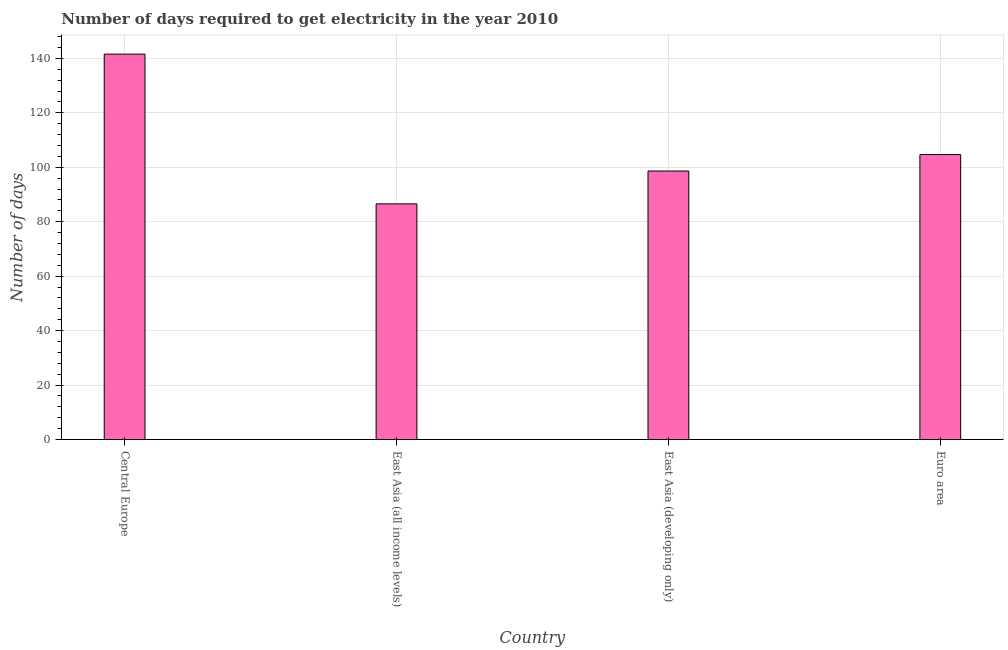Does the graph contain any zero values?
Keep it short and to the point. No. What is the title of the graph?
Provide a succinct answer. Number of days required to get electricity in the year 2010. What is the label or title of the X-axis?
Your answer should be very brief. Country. What is the label or title of the Y-axis?
Offer a very short reply. Number of days. What is the time to get electricity in East Asia (developing only)?
Make the answer very short. 98.61. Across all countries, what is the maximum time to get electricity?
Your answer should be compact. 141.55. Across all countries, what is the minimum time to get electricity?
Make the answer very short. 86.56. In which country was the time to get electricity maximum?
Your response must be concise. Central Europe. In which country was the time to get electricity minimum?
Give a very brief answer. East Asia (all income levels). What is the sum of the time to get electricity?
Ensure brevity in your answer.  431.38. What is the difference between the time to get electricity in Central Europe and East Asia (all income levels)?
Your answer should be compact. 54.98. What is the average time to get electricity per country?
Make the answer very short. 107.85. What is the median time to get electricity?
Provide a short and direct response. 101.64. In how many countries, is the time to get electricity greater than 40 ?
Your answer should be very brief. 4. What is the ratio of the time to get electricity in East Asia (all income levels) to that in East Asia (developing only)?
Your answer should be very brief. 0.88. Is the difference between the time to get electricity in East Asia (all income levels) and East Asia (developing only) greater than the difference between any two countries?
Offer a very short reply. No. What is the difference between the highest and the second highest time to get electricity?
Keep it short and to the point. 36.88. Is the sum of the time to get electricity in Central Europe and East Asia (all income levels) greater than the maximum time to get electricity across all countries?
Offer a terse response. Yes. What is the difference between the highest and the lowest time to get electricity?
Keep it short and to the point. 54.99. Are all the bars in the graph horizontal?
Offer a very short reply. No. How many countries are there in the graph?
Keep it short and to the point. 4. What is the difference between two consecutive major ticks on the Y-axis?
Make the answer very short. 20. What is the Number of days of Central Europe?
Keep it short and to the point. 141.55. What is the Number of days in East Asia (all income levels)?
Your response must be concise. 86.56. What is the Number of days of East Asia (developing only)?
Provide a short and direct response. 98.61. What is the Number of days of Euro area?
Make the answer very short. 104.67. What is the difference between the Number of days in Central Europe and East Asia (all income levels)?
Offer a very short reply. 54.99. What is the difference between the Number of days in Central Europe and East Asia (developing only)?
Your answer should be very brief. 42.93. What is the difference between the Number of days in Central Europe and Euro area?
Your answer should be compact. 36.88. What is the difference between the Number of days in East Asia (all income levels) and East Asia (developing only)?
Your response must be concise. -12.05. What is the difference between the Number of days in East Asia (all income levels) and Euro area?
Make the answer very short. -18.11. What is the difference between the Number of days in East Asia (developing only) and Euro area?
Make the answer very short. -6.06. What is the ratio of the Number of days in Central Europe to that in East Asia (all income levels)?
Your answer should be very brief. 1.64. What is the ratio of the Number of days in Central Europe to that in East Asia (developing only)?
Offer a terse response. 1.44. What is the ratio of the Number of days in Central Europe to that in Euro area?
Your answer should be very brief. 1.35. What is the ratio of the Number of days in East Asia (all income levels) to that in East Asia (developing only)?
Your answer should be very brief. 0.88. What is the ratio of the Number of days in East Asia (all income levels) to that in Euro area?
Ensure brevity in your answer.  0.83. What is the ratio of the Number of days in East Asia (developing only) to that in Euro area?
Give a very brief answer. 0.94. 